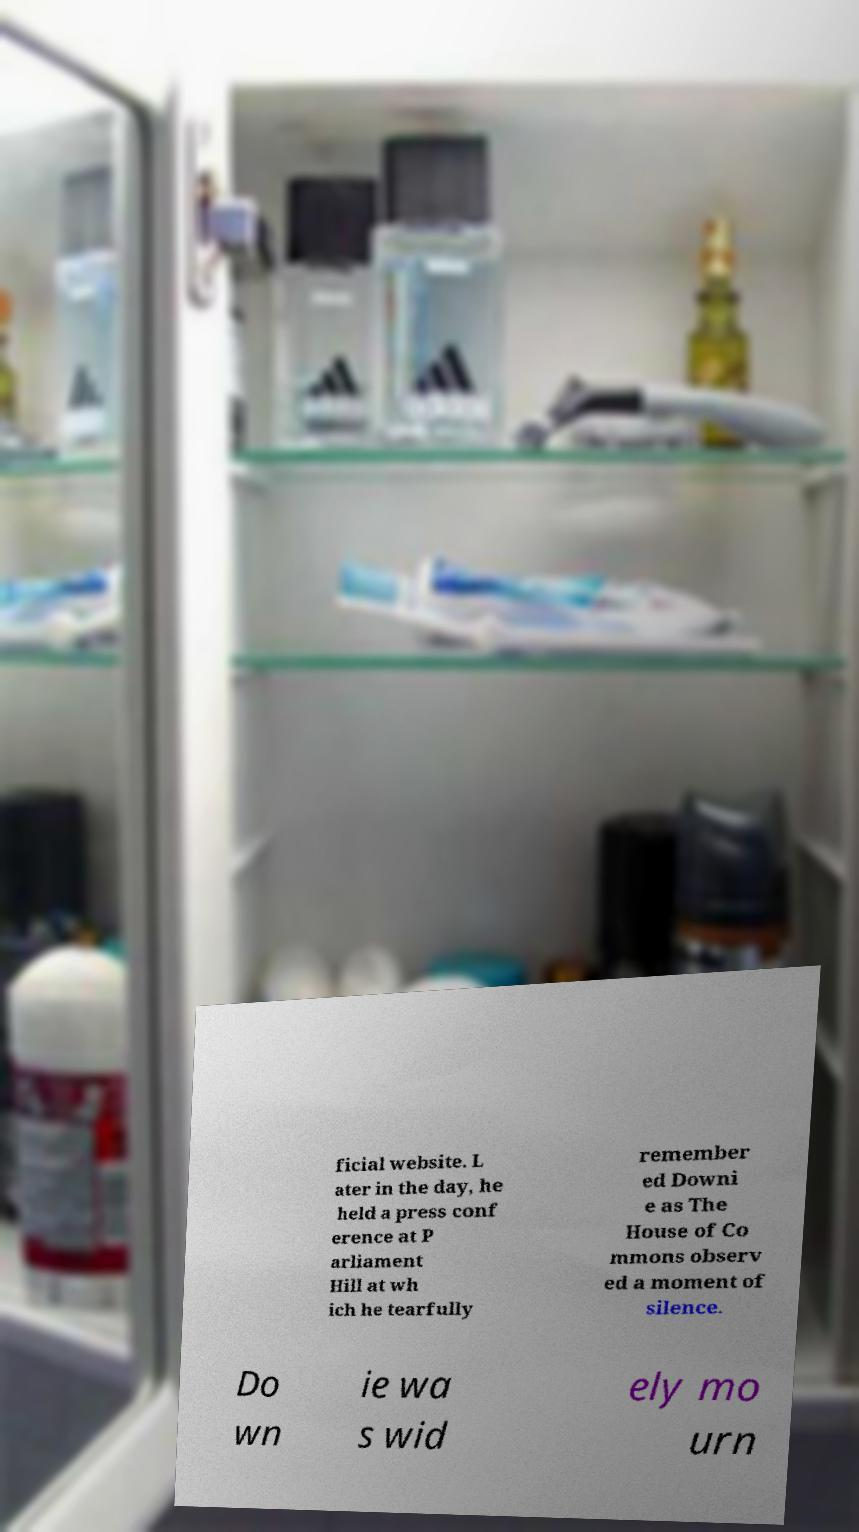Could you extract and type out the text from this image? ficial website. L ater in the day, he held a press conf erence at P arliament Hill at wh ich he tearfully remember ed Downi e as The House of Co mmons observ ed a moment of silence. Do wn ie wa s wid ely mo urn 